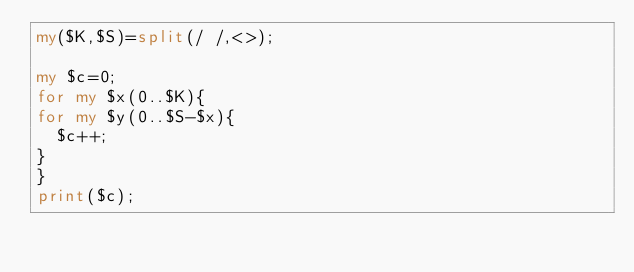<code> <loc_0><loc_0><loc_500><loc_500><_Perl_>my($K,$S)=split(/ /,<>);

my $c=0;
for my $x(0..$K){
for my $y(0..$S-$x){
  $c++;
}
}
print($c);</code> 